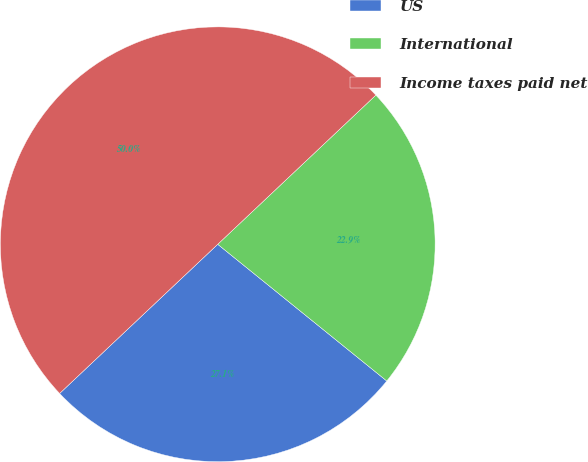Convert chart to OTSL. <chart><loc_0><loc_0><loc_500><loc_500><pie_chart><fcel>US<fcel>International<fcel>Income taxes paid net<nl><fcel>27.14%<fcel>22.86%<fcel>50.0%<nl></chart> 